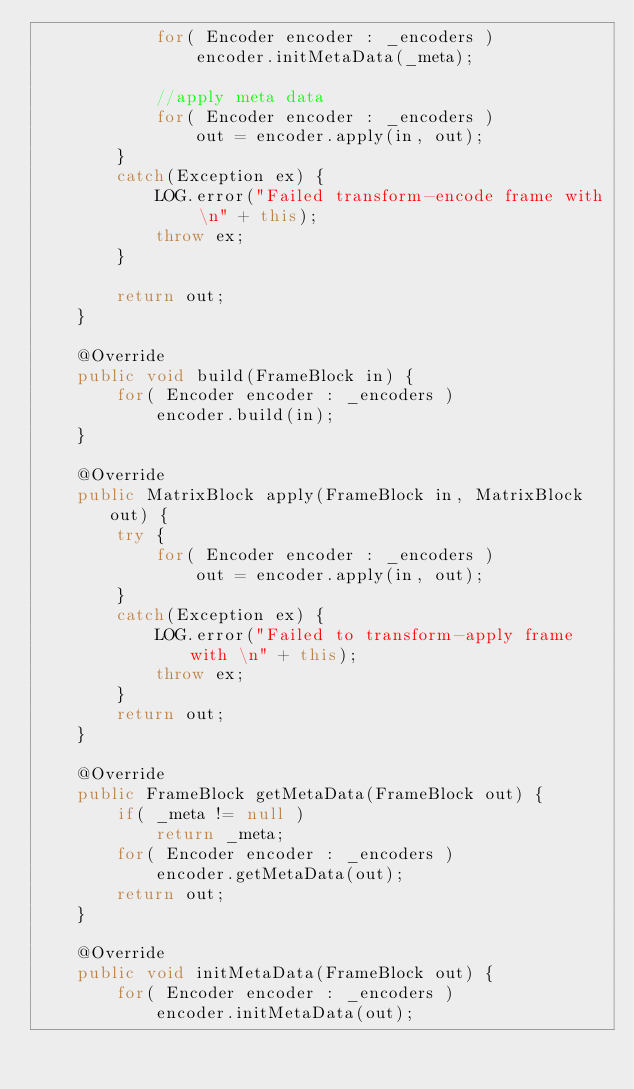Convert code to text. <code><loc_0><loc_0><loc_500><loc_500><_Java_>			for( Encoder encoder : _encoders )
				encoder.initMetaData(_meta);
			
			//apply meta data
			for( Encoder encoder : _encoders )
				out = encoder.apply(in, out);
		}
		catch(Exception ex) {
			LOG.error("Failed transform-encode frame with \n" + this);
			throw ex;
		}
		
		return out;
	}

	@Override
	public void build(FrameBlock in) {
		for( Encoder encoder : _encoders )
			encoder.build(in);
	}
	
	@Override 
	public MatrixBlock apply(FrameBlock in, MatrixBlock out) {
		try {
			for( Encoder encoder : _encoders )
				out = encoder.apply(in, out);
		}
		catch(Exception ex) {
			LOG.error("Failed to transform-apply frame with \n" + this);
			throw ex;
		}
		return out;
	}
	
	@Override
	public FrameBlock getMetaData(FrameBlock out) {
		if( _meta != null )
			return _meta;
		for( Encoder encoder : _encoders )
			encoder.getMetaData(out);
		return out;
	}
	
	@Override
	public void initMetaData(FrameBlock out) {
		for( Encoder encoder : _encoders )
			encoder.initMetaData(out);</code> 